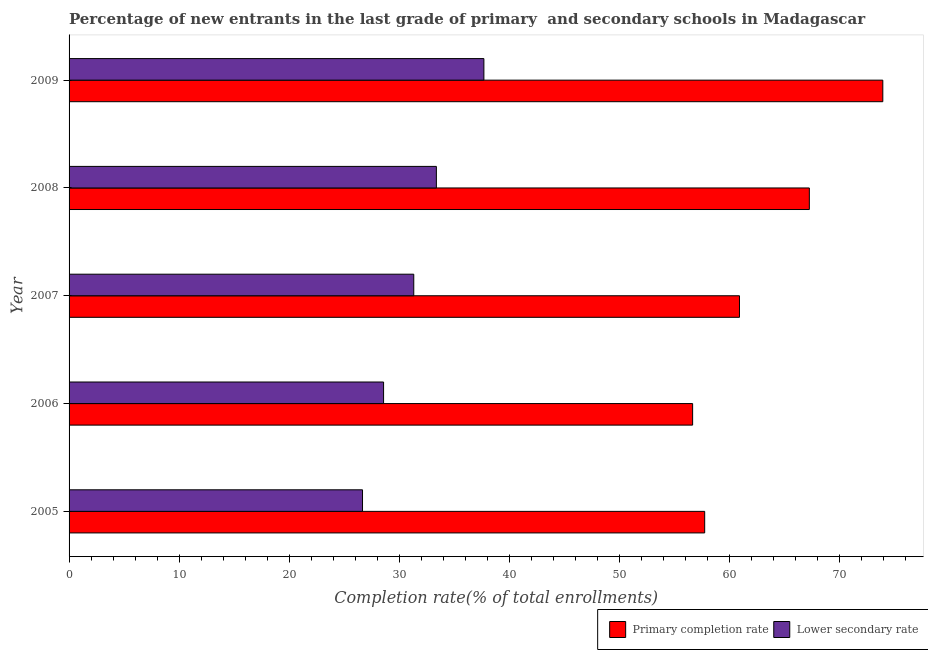Are the number of bars per tick equal to the number of legend labels?
Offer a terse response. Yes. How many bars are there on the 1st tick from the bottom?
Your response must be concise. 2. What is the label of the 4th group of bars from the top?
Make the answer very short. 2006. What is the completion rate in primary schools in 2005?
Make the answer very short. 57.77. Across all years, what is the maximum completion rate in primary schools?
Offer a terse response. 73.96. Across all years, what is the minimum completion rate in primary schools?
Provide a succinct answer. 56.68. In which year was the completion rate in secondary schools minimum?
Your answer should be very brief. 2005. What is the total completion rate in primary schools in the graph?
Offer a terse response. 316.63. What is the difference between the completion rate in primary schools in 2006 and that in 2007?
Offer a very short reply. -4.26. What is the difference between the completion rate in secondary schools in 2006 and the completion rate in primary schools in 2008?
Ensure brevity in your answer.  -38.7. What is the average completion rate in primary schools per year?
Make the answer very short. 63.33. In the year 2008, what is the difference between the completion rate in primary schools and completion rate in secondary schools?
Provide a succinct answer. 33.9. What is the ratio of the completion rate in secondary schools in 2006 to that in 2009?
Your answer should be very brief. 0.76. Is the difference between the completion rate in primary schools in 2005 and 2009 greater than the difference between the completion rate in secondary schools in 2005 and 2009?
Give a very brief answer. No. What is the difference between the highest and the second highest completion rate in primary schools?
Give a very brief answer. 6.68. What is the difference between the highest and the lowest completion rate in primary schools?
Provide a short and direct response. 17.29. Is the sum of the completion rate in secondary schools in 2008 and 2009 greater than the maximum completion rate in primary schools across all years?
Make the answer very short. No. What does the 1st bar from the top in 2008 represents?
Offer a very short reply. Lower secondary rate. What does the 1st bar from the bottom in 2009 represents?
Offer a very short reply. Primary completion rate. How many years are there in the graph?
Your answer should be very brief. 5. Are the values on the major ticks of X-axis written in scientific E-notation?
Your response must be concise. No. Does the graph contain any zero values?
Provide a short and direct response. No. Where does the legend appear in the graph?
Offer a terse response. Bottom right. How are the legend labels stacked?
Ensure brevity in your answer.  Horizontal. What is the title of the graph?
Provide a short and direct response. Percentage of new entrants in the last grade of primary  and secondary schools in Madagascar. What is the label or title of the X-axis?
Provide a short and direct response. Completion rate(% of total enrollments). What is the label or title of the Y-axis?
Offer a very short reply. Year. What is the Completion rate(% of total enrollments) in Primary completion rate in 2005?
Give a very brief answer. 57.77. What is the Completion rate(% of total enrollments) of Lower secondary rate in 2005?
Provide a succinct answer. 26.67. What is the Completion rate(% of total enrollments) of Primary completion rate in 2006?
Ensure brevity in your answer.  56.68. What is the Completion rate(% of total enrollments) of Lower secondary rate in 2006?
Your answer should be compact. 28.59. What is the Completion rate(% of total enrollments) in Primary completion rate in 2007?
Your answer should be very brief. 60.94. What is the Completion rate(% of total enrollments) of Lower secondary rate in 2007?
Your answer should be very brief. 31.33. What is the Completion rate(% of total enrollments) of Primary completion rate in 2008?
Provide a short and direct response. 67.29. What is the Completion rate(% of total enrollments) in Lower secondary rate in 2008?
Your response must be concise. 33.39. What is the Completion rate(% of total enrollments) in Primary completion rate in 2009?
Give a very brief answer. 73.96. What is the Completion rate(% of total enrollments) of Lower secondary rate in 2009?
Provide a short and direct response. 37.7. Across all years, what is the maximum Completion rate(% of total enrollments) of Primary completion rate?
Make the answer very short. 73.96. Across all years, what is the maximum Completion rate(% of total enrollments) in Lower secondary rate?
Give a very brief answer. 37.7. Across all years, what is the minimum Completion rate(% of total enrollments) in Primary completion rate?
Make the answer very short. 56.68. Across all years, what is the minimum Completion rate(% of total enrollments) in Lower secondary rate?
Offer a terse response. 26.67. What is the total Completion rate(% of total enrollments) in Primary completion rate in the graph?
Provide a succinct answer. 316.63. What is the total Completion rate(% of total enrollments) in Lower secondary rate in the graph?
Provide a succinct answer. 157.68. What is the difference between the Completion rate(% of total enrollments) of Primary completion rate in 2005 and that in 2006?
Keep it short and to the point. 1.1. What is the difference between the Completion rate(% of total enrollments) of Lower secondary rate in 2005 and that in 2006?
Offer a terse response. -1.91. What is the difference between the Completion rate(% of total enrollments) in Primary completion rate in 2005 and that in 2007?
Your response must be concise. -3.16. What is the difference between the Completion rate(% of total enrollments) of Lower secondary rate in 2005 and that in 2007?
Provide a succinct answer. -4.66. What is the difference between the Completion rate(% of total enrollments) in Primary completion rate in 2005 and that in 2008?
Your response must be concise. -9.51. What is the difference between the Completion rate(% of total enrollments) in Lower secondary rate in 2005 and that in 2008?
Give a very brief answer. -6.71. What is the difference between the Completion rate(% of total enrollments) in Primary completion rate in 2005 and that in 2009?
Keep it short and to the point. -16.19. What is the difference between the Completion rate(% of total enrollments) of Lower secondary rate in 2005 and that in 2009?
Provide a short and direct response. -11.03. What is the difference between the Completion rate(% of total enrollments) of Primary completion rate in 2006 and that in 2007?
Give a very brief answer. -4.26. What is the difference between the Completion rate(% of total enrollments) in Lower secondary rate in 2006 and that in 2007?
Give a very brief answer. -2.74. What is the difference between the Completion rate(% of total enrollments) in Primary completion rate in 2006 and that in 2008?
Offer a very short reply. -10.61. What is the difference between the Completion rate(% of total enrollments) of Lower secondary rate in 2006 and that in 2008?
Give a very brief answer. -4.8. What is the difference between the Completion rate(% of total enrollments) in Primary completion rate in 2006 and that in 2009?
Ensure brevity in your answer.  -17.29. What is the difference between the Completion rate(% of total enrollments) of Lower secondary rate in 2006 and that in 2009?
Give a very brief answer. -9.12. What is the difference between the Completion rate(% of total enrollments) of Primary completion rate in 2007 and that in 2008?
Give a very brief answer. -6.35. What is the difference between the Completion rate(% of total enrollments) in Lower secondary rate in 2007 and that in 2008?
Ensure brevity in your answer.  -2.05. What is the difference between the Completion rate(% of total enrollments) of Primary completion rate in 2007 and that in 2009?
Keep it short and to the point. -13.03. What is the difference between the Completion rate(% of total enrollments) in Lower secondary rate in 2007 and that in 2009?
Offer a terse response. -6.37. What is the difference between the Completion rate(% of total enrollments) in Primary completion rate in 2008 and that in 2009?
Offer a terse response. -6.68. What is the difference between the Completion rate(% of total enrollments) in Lower secondary rate in 2008 and that in 2009?
Your response must be concise. -4.32. What is the difference between the Completion rate(% of total enrollments) of Primary completion rate in 2005 and the Completion rate(% of total enrollments) of Lower secondary rate in 2006?
Provide a short and direct response. 29.19. What is the difference between the Completion rate(% of total enrollments) of Primary completion rate in 2005 and the Completion rate(% of total enrollments) of Lower secondary rate in 2007?
Offer a very short reply. 26.44. What is the difference between the Completion rate(% of total enrollments) of Primary completion rate in 2005 and the Completion rate(% of total enrollments) of Lower secondary rate in 2008?
Make the answer very short. 24.39. What is the difference between the Completion rate(% of total enrollments) of Primary completion rate in 2005 and the Completion rate(% of total enrollments) of Lower secondary rate in 2009?
Keep it short and to the point. 20.07. What is the difference between the Completion rate(% of total enrollments) in Primary completion rate in 2006 and the Completion rate(% of total enrollments) in Lower secondary rate in 2007?
Give a very brief answer. 25.35. What is the difference between the Completion rate(% of total enrollments) of Primary completion rate in 2006 and the Completion rate(% of total enrollments) of Lower secondary rate in 2008?
Keep it short and to the point. 23.29. What is the difference between the Completion rate(% of total enrollments) in Primary completion rate in 2006 and the Completion rate(% of total enrollments) in Lower secondary rate in 2009?
Your response must be concise. 18.97. What is the difference between the Completion rate(% of total enrollments) of Primary completion rate in 2007 and the Completion rate(% of total enrollments) of Lower secondary rate in 2008?
Keep it short and to the point. 27.55. What is the difference between the Completion rate(% of total enrollments) of Primary completion rate in 2007 and the Completion rate(% of total enrollments) of Lower secondary rate in 2009?
Your answer should be very brief. 23.23. What is the difference between the Completion rate(% of total enrollments) of Primary completion rate in 2008 and the Completion rate(% of total enrollments) of Lower secondary rate in 2009?
Offer a terse response. 29.58. What is the average Completion rate(% of total enrollments) in Primary completion rate per year?
Offer a terse response. 63.33. What is the average Completion rate(% of total enrollments) in Lower secondary rate per year?
Offer a terse response. 31.54. In the year 2005, what is the difference between the Completion rate(% of total enrollments) of Primary completion rate and Completion rate(% of total enrollments) of Lower secondary rate?
Ensure brevity in your answer.  31.1. In the year 2006, what is the difference between the Completion rate(% of total enrollments) in Primary completion rate and Completion rate(% of total enrollments) in Lower secondary rate?
Keep it short and to the point. 28.09. In the year 2007, what is the difference between the Completion rate(% of total enrollments) of Primary completion rate and Completion rate(% of total enrollments) of Lower secondary rate?
Your response must be concise. 29.61. In the year 2008, what is the difference between the Completion rate(% of total enrollments) of Primary completion rate and Completion rate(% of total enrollments) of Lower secondary rate?
Ensure brevity in your answer.  33.9. In the year 2009, what is the difference between the Completion rate(% of total enrollments) in Primary completion rate and Completion rate(% of total enrollments) in Lower secondary rate?
Offer a very short reply. 36.26. What is the ratio of the Completion rate(% of total enrollments) in Primary completion rate in 2005 to that in 2006?
Make the answer very short. 1.02. What is the ratio of the Completion rate(% of total enrollments) of Lower secondary rate in 2005 to that in 2006?
Offer a terse response. 0.93. What is the ratio of the Completion rate(% of total enrollments) of Primary completion rate in 2005 to that in 2007?
Offer a very short reply. 0.95. What is the ratio of the Completion rate(% of total enrollments) in Lower secondary rate in 2005 to that in 2007?
Make the answer very short. 0.85. What is the ratio of the Completion rate(% of total enrollments) of Primary completion rate in 2005 to that in 2008?
Your answer should be very brief. 0.86. What is the ratio of the Completion rate(% of total enrollments) of Lower secondary rate in 2005 to that in 2008?
Offer a terse response. 0.8. What is the ratio of the Completion rate(% of total enrollments) in Primary completion rate in 2005 to that in 2009?
Keep it short and to the point. 0.78. What is the ratio of the Completion rate(% of total enrollments) in Lower secondary rate in 2005 to that in 2009?
Your answer should be very brief. 0.71. What is the ratio of the Completion rate(% of total enrollments) of Primary completion rate in 2006 to that in 2007?
Ensure brevity in your answer.  0.93. What is the ratio of the Completion rate(% of total enrollments) of Lower secondary rate in 2006 to that in 2007?
Provide a succinct answer. 0.91. What is the ratio of the Completion rate(% of total enrollments) in Primary completion rate in 2006 to that in 2008?
Your response must be concise. 0.84. What is the ratio of the Completion rate(% of total enrollments) in Lower secondary rate in 2006 to that in 2008?
Your response must be concise. 0.86. What is the ratio of the Completion rate(% of total enrollments) in Primary completion rate in 2006 to that in 2009?
Your answer should be very brief. 0.77. What is the ratio of the Completion rate(% of total enrollments) in Lower secondary rate in 2006 to that in 2009?
Provide a succinct answer. 0.76. What is the ratio of the Completion rate(% of total enrollments) of Primary completion rate in 2007 to that in 2008?
Provide a short and direct response. 0.91. What is the ratio of the Completion rate(% of total enrollments) of Lower secondary rate in 2007 to that in 2008?
Provide a succinct answer. 0.94. What is the ratio of the Completion rate(% of total enrollments) in Primary completion rate in 2007 to that in 2009?
Give a very brief answer. 0.82. What is the ratio of the Completion rate(% of total enrollments) of Lower secondary rate in 2007 to that in 2009?
Offer a very short reply. 0.83. What is the ratio of the Completion rate(% of total enrollments) in Primary completion rate in 2008 to that in 2009?
Ensure brevity in your answer.  0.91. What is the ratio of the Completion rate(% of total enrollments) of Lower secondary rate in 2008 to that in 2009?
Make the answer very short. 0.89. What is the difference between the highest and the second highest Completion rate(% of total enrollments) of Primary completion rate?
Make the answer very short. 6.68. What is the difference between the highest and the second highest Completion rate(% of total enrollments) of Lower secondary rate?
Offer a terse response. 4.32. What is the difference between the highest and the lowest Completion rate(% of total enrollments) in Primary completion rate?
Ensure brevity in your answer.  17.29. What is the difference between the highest and the lowest Completion rate(% of total enrollments) of Lower secondary rate?
Keep it short and to the point. 11.03. 